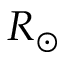<formula> <loc_0><loc_0><loc_500><loc_500>R _ { \odot }</formula> 